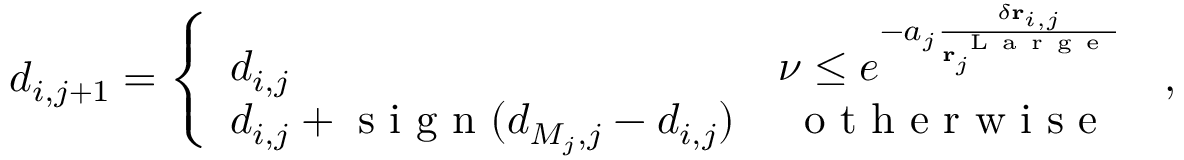Convert formula to latex. <formula><loc_0><loc_0><loc_500><loc_500>\begin{array} { r } { d _ { i , j + 1 } = \left \{ \begin{array} { l l } { d _ { i , j } } & { \nu \leq e ^ { - a _ { j } \frac { \delta r _ { i , j } } { r _ { j } ^ { L a r g e } } } } \\ { d _ { i , j } + s i g n ( d _ { M _ { j } , j } - d _ { i , j } ) } & { \, o t h e r w i s e } \end{array} \, , } \end{array}</formula> 